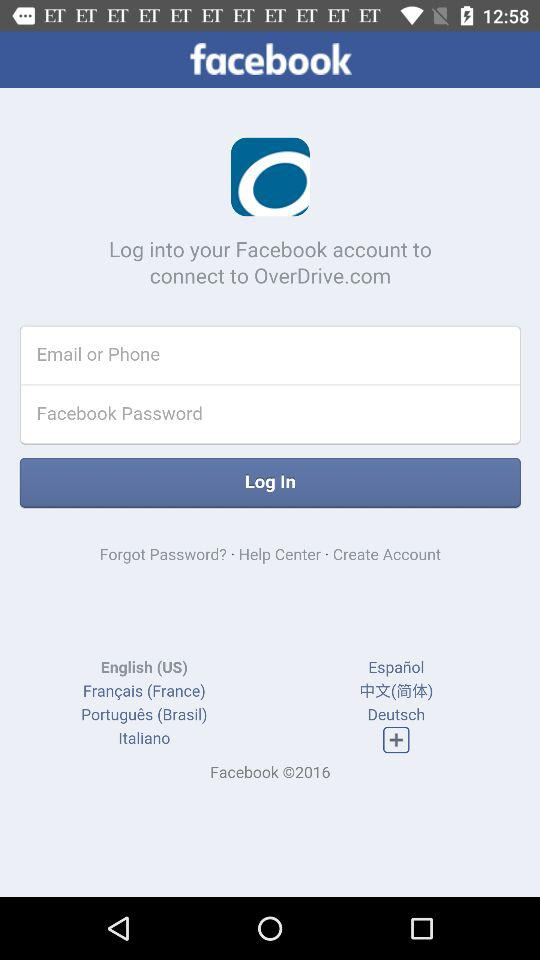How many languages are available on this screen?
Answer the question using a single word or phrase. 7 